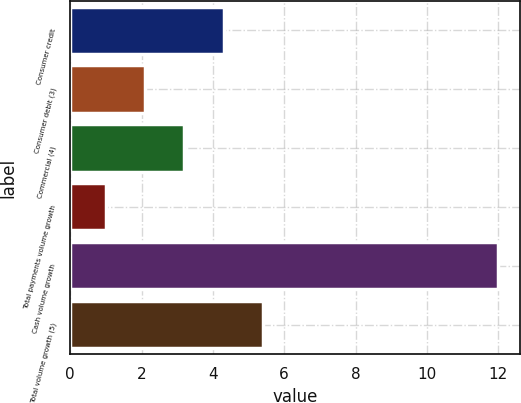<chart> <loc_0><loc_0><loc_500><loc_500><bar_chart><fcel>Consumer credit<fcel>Consumer debit (3)<fcel>Commercial (4)<fcel>Total payments volume growth<fcel>Cash volume growth<fcel>Total volume growth (5)<nl><fcel>4.3<fcel>2.1<fcel>3.2<fcel>1<fcel>12<fcel>5.4<nl></chart> 